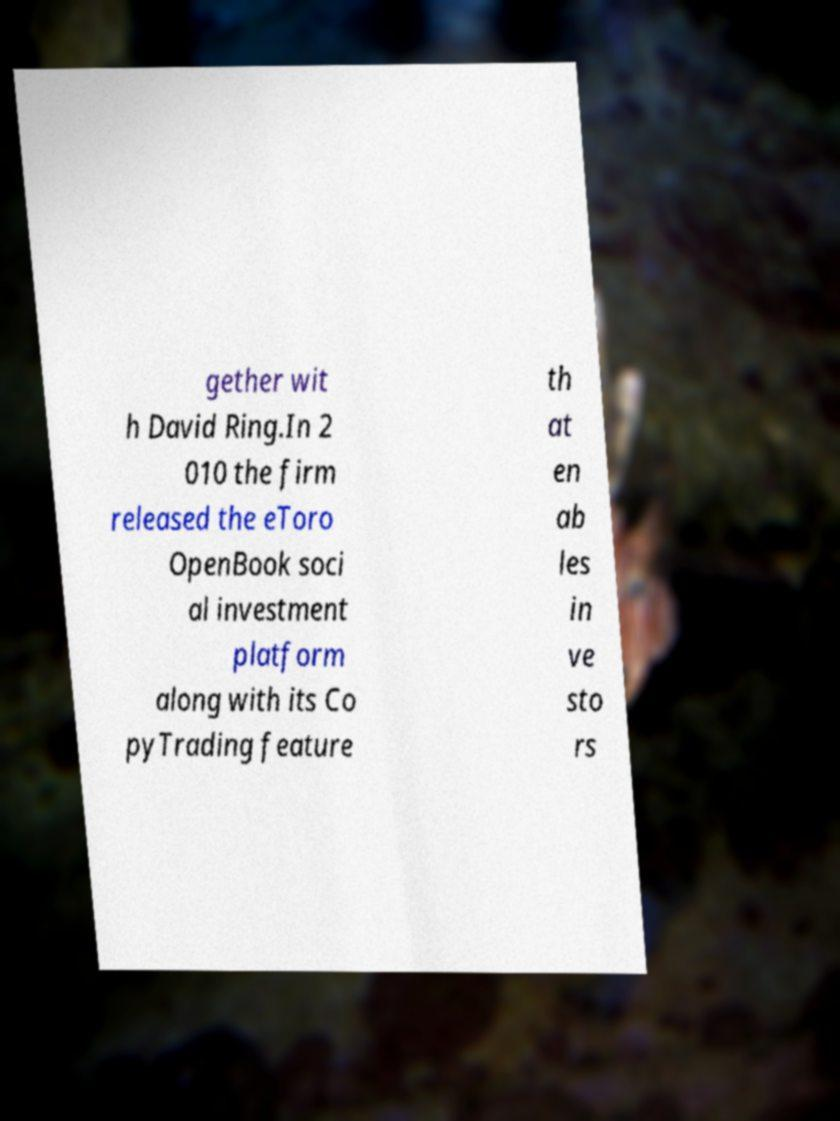There's text embedded in this image that I need extracted. Can you transcribe it verbatim? gether wit h David Ring.In 2 010 the firm released the eToro OpenBook soci al investment platform along with its Co pyTrading feature th at en ab les in ve sto rs 